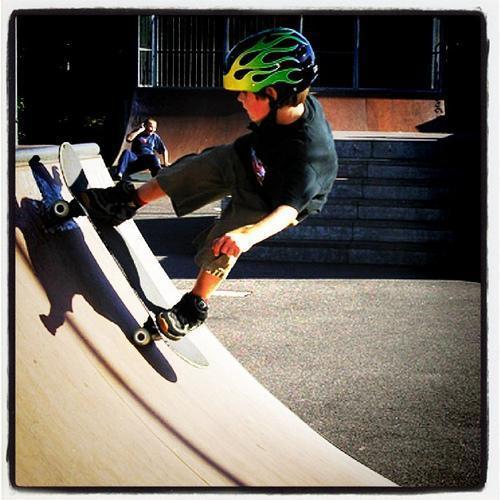How many people are in the picture?
Give a very brief answer. 2. 